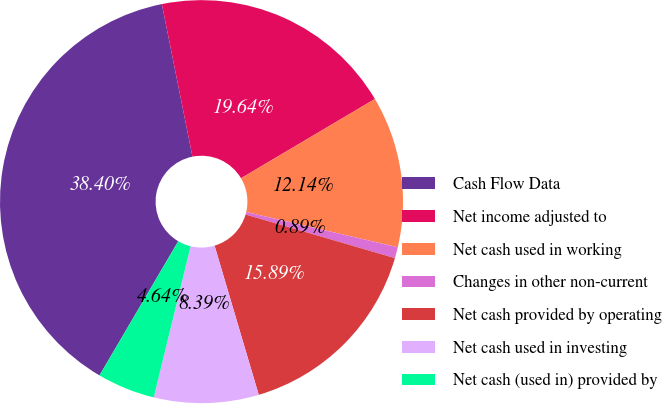Convert chart to OTSL. <chart><loc_0><loc_0><loc_500><loc_500><pie_chart><fcel>Cash Flow Data<fcel>Net income adjusted to<fcel>Net cash used in working<fcel>Changes in other non-current<fcel>Net cash provided by operating<fcel>Net cash used in investing<fcel>Net cash (used in) provided by<nl><fcel>38.39%<fcel>19.64%<fcel>12.14%<fcel>0.89%<fcel>15.89%<fcel>8.39%<fcel>4.64%<nl></chart> 